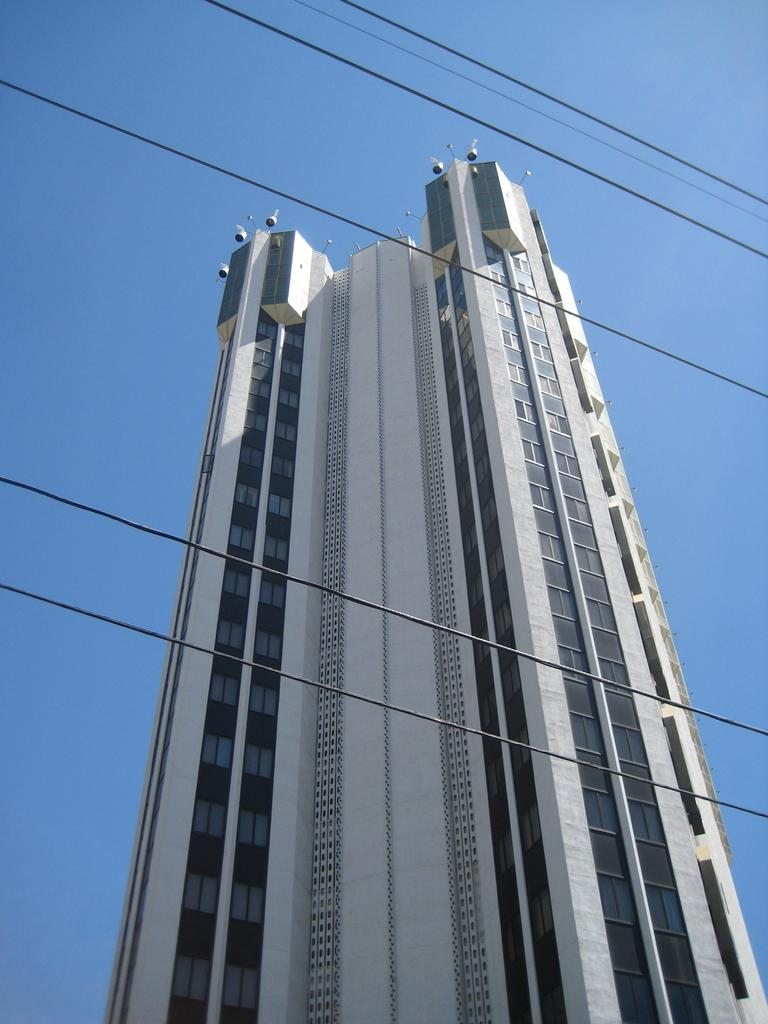What is the main subject in the center of the image? There is a building in the center of the image. What else can be seen in the image besides the building? Wires are visible in the image. What is visible in the background of the image? The sky is visible in the background of the image. How many rabbits can be seen hopping around the building in the image? There are no rabbits present in the image; it only features a building and wires. 